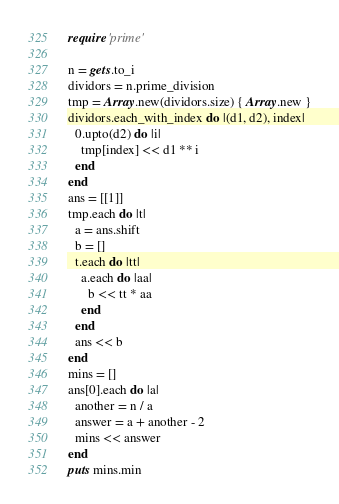Convert code to text. <code><loc_0><loc_0><loc_500><loc_500><_Ruby_>require 'prime'

n = gets.to_i
dividors = n.prime_division
tmp = Array.new(dividors.size) { Array.new }
dividors.each_with_index do |(d1, d2), index|
  0.upto(d2) do |i|
    tmp[index] << d1 ** i
  end
end
ans = [[1]]
tmp.each do |t|
  a = ans.shift
  b = []
  t.each do |tt|
    a.each do |aa|
      b << tt * aa
    end
  end
  ans << b
end
mins = []
ans[0].each do |a|
  another = n / a
  answer = a + another - 2
  mins << answer
end
puts mins.min
</code> 